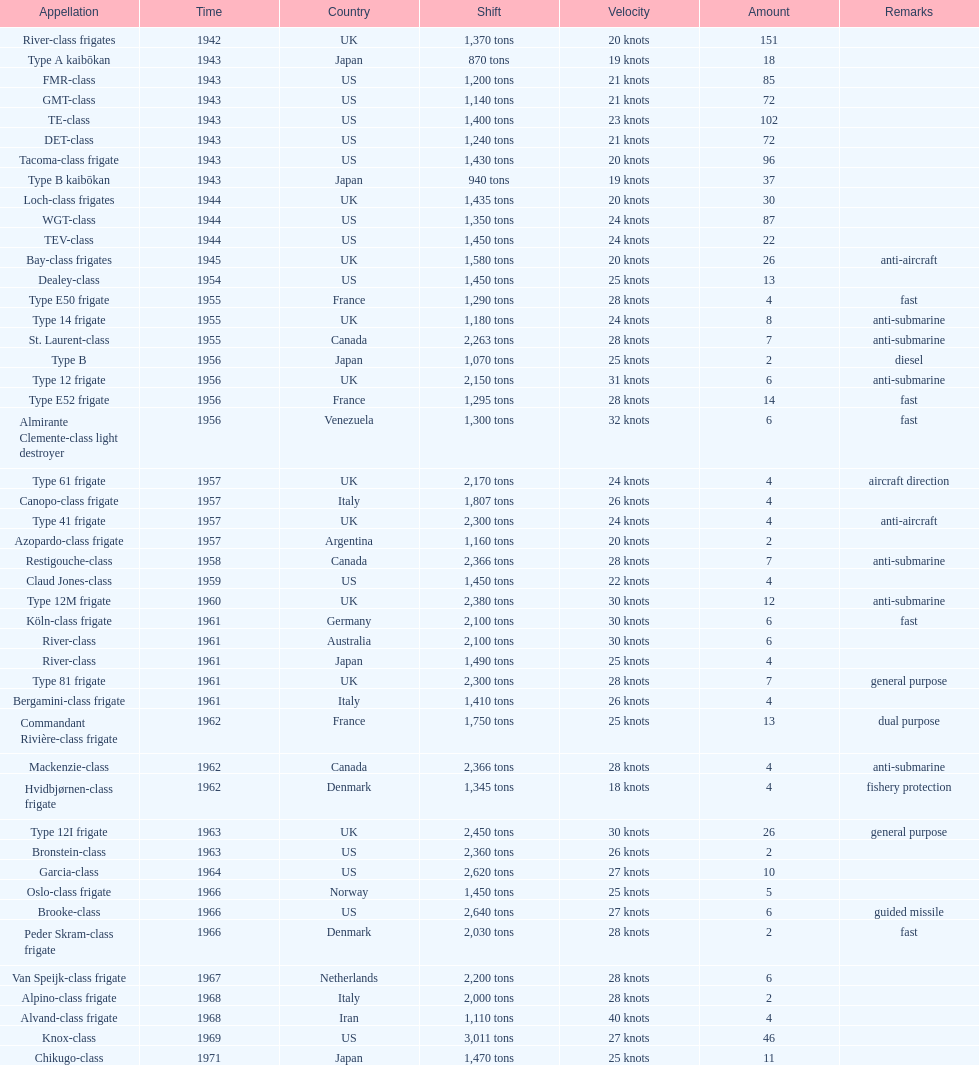How many tons of displacement does type b have? 940 tons. 